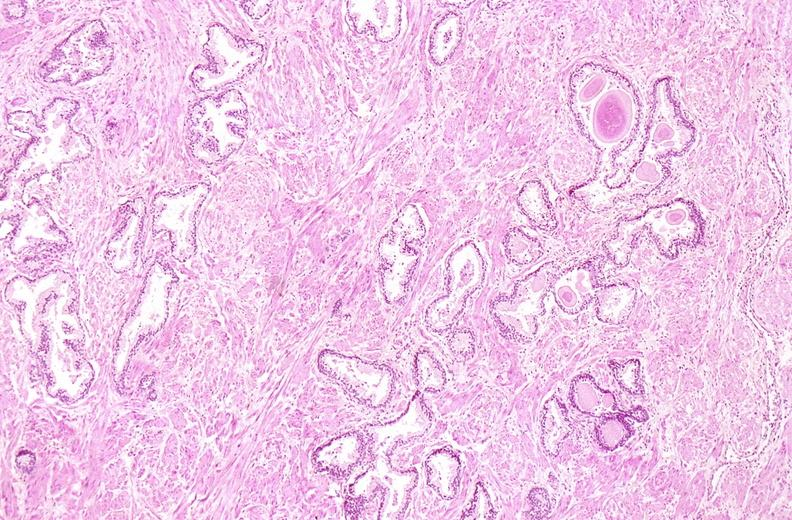does this image show prostate, normal histology?
Answer the question using a single word or phrase. Yes 